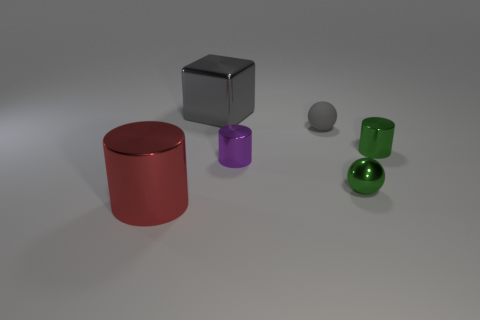Add 4 gray shiny blocks. How many objects exist? 10 Subtract all spheres. How many objects are left? 4 Subtract 0 green cubes. How many objects are left? 6 Subtract all large gray metallic cubes. Subtract all tiny things. How many objects are left? 1 Add 4 tiny green shiny cylinders. How many tiny green shiny cylinders are left? 5 Add 1 tiny purple cylinders. How many tiny purple cylinders exist? 2 